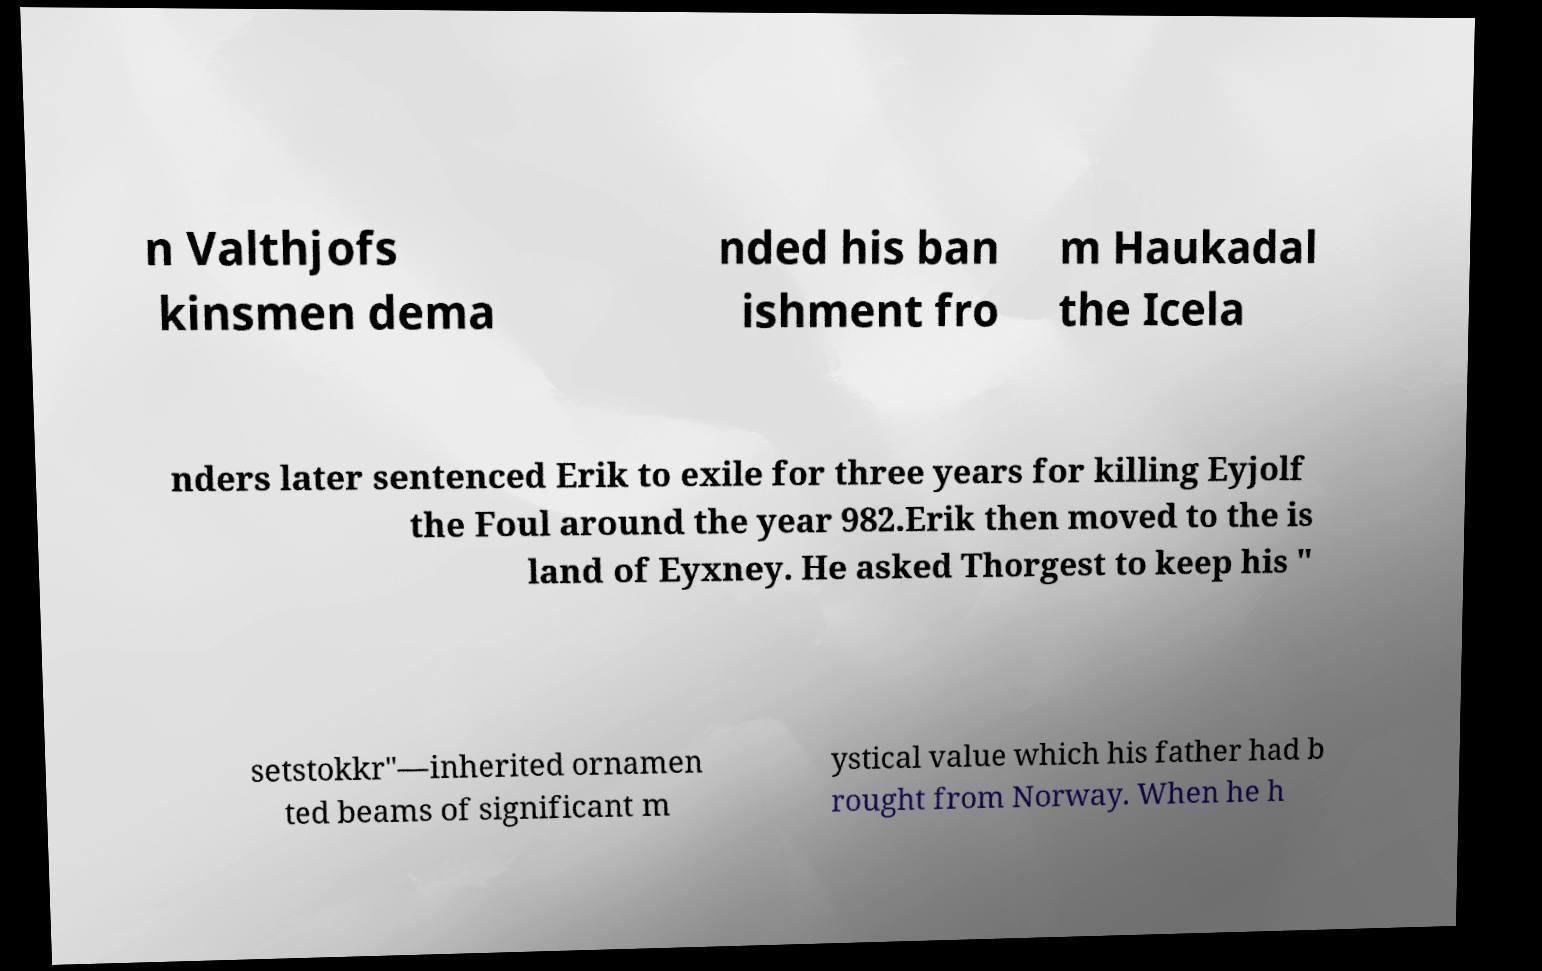Please read and relay the text visible in this image. What does it say? n Valthjofs kinsmen dema nded his ban ishment fro m Haukadal the Icela nders later sentenced Erik to exile for three years for killing Eyjolf the Foul around the year 982.Erik then moved to the is land of Eyxney. He asked Thorgest to keep his " setstokkr"—inherited ornamen ted beams of significant m ystical value which his father had b rought from Norway. When he h 